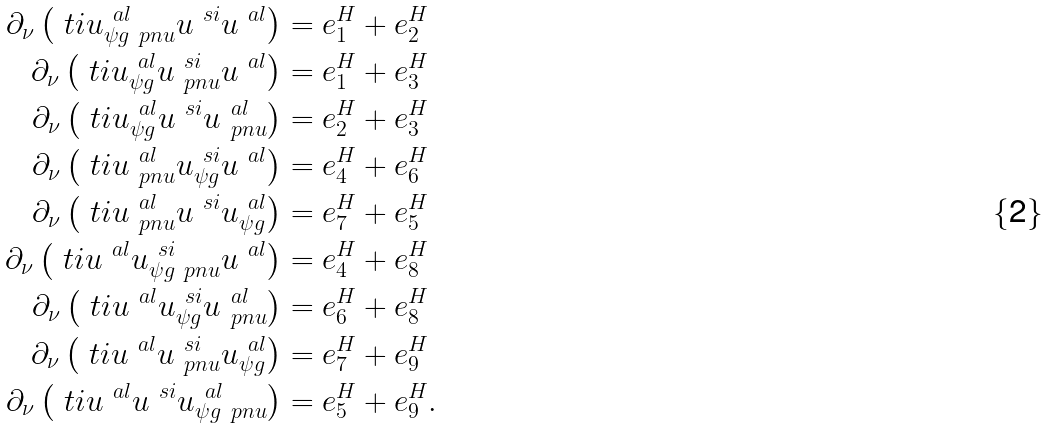Convert formula to latex. <formula><loc_0><loc_0><loc_500><loc_500>\partial _ { \nu } \left ( \ t i { u } ^ { \ a l } _ { \psi g \ p n u } u ^ { \ s i } u ^ { \ a l } \right ) & = e ^ { H } _ { 1 } + e ^ { H } _ { 2 } \\ \partial _ { \nu } \left ( \ t i { u } ^ { \ a l } _ { \psi g } u ^ { \ s i } _ { \ p n u } u ^ { \ a l } \right ) & = e ^ { H } _ { 1 } + e ^ { H } _ { 3 } \\ \partial _ { \nu } \left ( \ t i { u } ^ { \ a l } _ { \psi g } u ^ { \ s i } u ^ { \ a l } _ { \ p n u } \right ) & = e ^ { H } _ { 2 } + e ^ { H } _ { 3 } \\ \partial _ { \nu } \left ( \ t i { u } ^ { \ a l } _ { \ p n u } u ^ { \ s i } _ { \psi g } u ^ { \ a l } \right ) & = e ^ { H } _ { 4 } + e ^ { H } _ { 6 } \\ \partial _ { \nu } \left ( \ t i { u } ^ { \ a l } _ { \ p n u } u ^ { \ s i } u ^ { \ a l } _ { \psi g } \right ) & = e ^ { H } _ { 7 } + e ^ { H } _ { 5 } \\ \partial _ { \nu } \left ( \ t i { u } ^ { \ a l } u ^ { \ s i } _ { \psi g \ p n u } u ^ { \ a l } \right ) & = e ^ { H } _ { 4 } + e ^ { H } _ { 8 } \\ \partial _ { \nu } \left ( \ t i { u } ^ { \ a l } u ^ { \ s i } _ { \psi g } u ^ { \ a l } _ { \ p n u } \right ) & = e ^ { H } _ { 6 } + e ^ { H } _ { 8 } \\ \partial _ { \nu } \left ( \ t i { u } ^ { \ a l } u ^ { \ s i } _ { \ p n u } u ^ { \ a l } _ { \psi g } \right ) & = e ^ { H } _ { 7 } + e ^ { H } _ { 9 } \\ \partial _ { \nu } \left ( \ t i { u } ^ { \ a l } u ^ { \ s i } u ^ { \ a l } _ { \psi g \ p n u } \right ) & = e ^ { H } _ { 5 } + e ^ { H } _ { 9 } .</formula> 